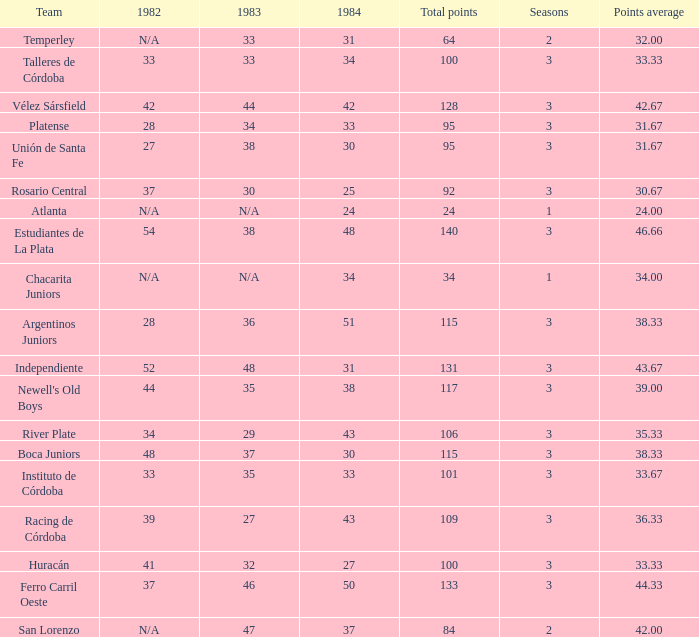What is the total for 1984 for the team with 100 points total and more than 3 seasons? None. 